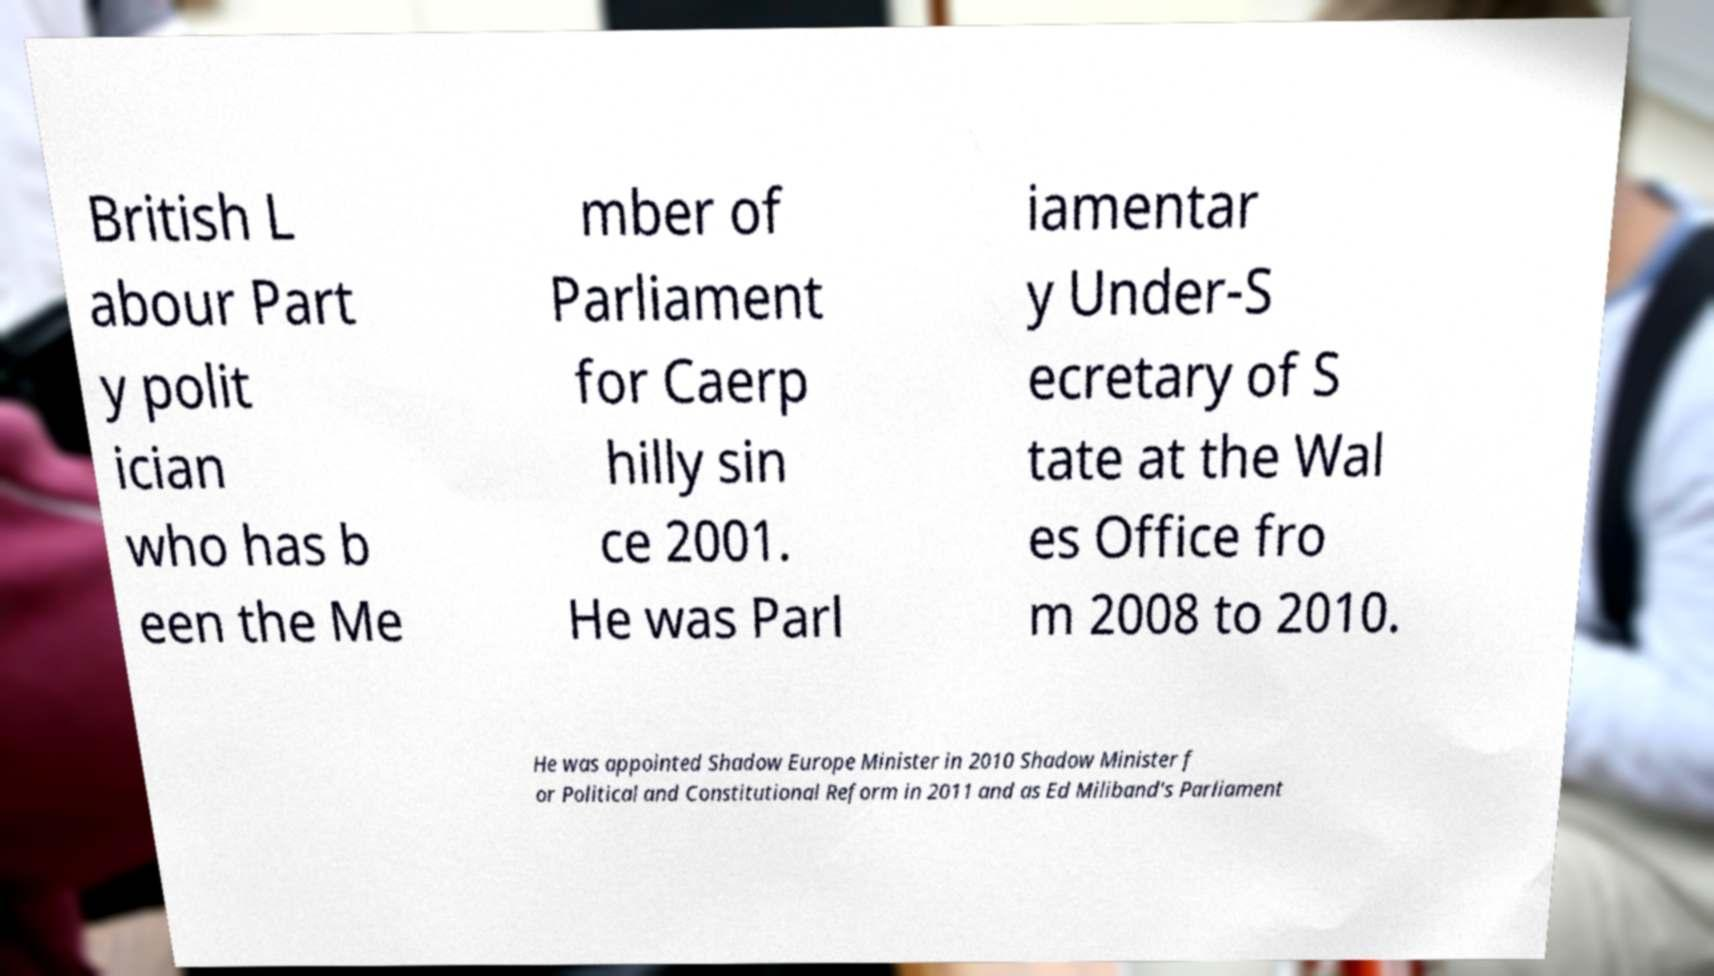Can you read and provide the text displayed in the image?This photo seems to have some interesting text. Can you extract and type it out for me? British L abour Part y polit ician who has b een the Me mber of Parliament for Caerp hilly sin ce 2001. He was Parl iamentar y Under-S ecretary of S tate at the Wal es Office fro m 2008 to 2010. He was appointed Shadow Europe Minister in 2010 Shadow Minister f or Political and Constitutional Reform in 2011 and as Ed Miliband's Parliament 